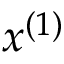Convert formula to latex. <formula><loc_0><loc_0><loc_500><loc_500>x ^ { ( 1 ) }</formula> 